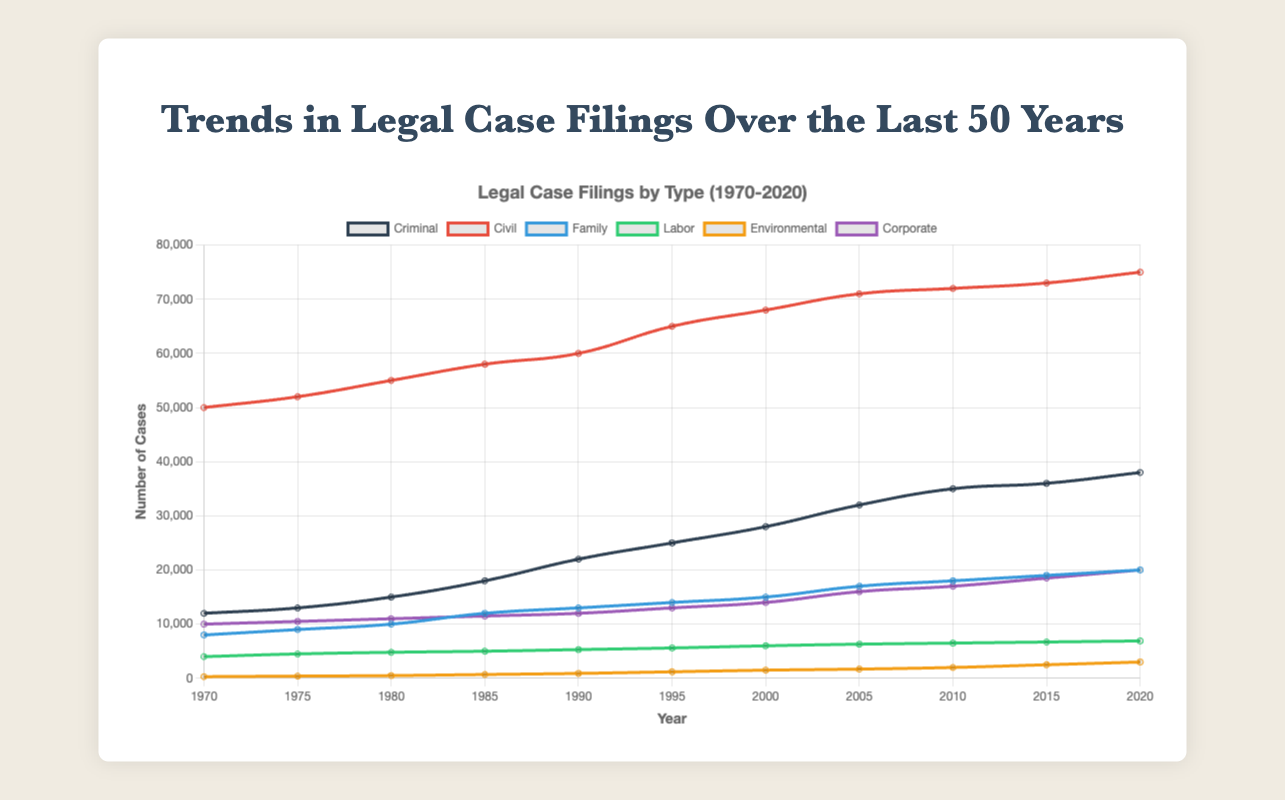What's the general trend in the number of criminal cases from 1970 to 2020? Observing the line for "Criminal" cases in the plot, there is a general upward trend. Starting at 12,000 cases in 1970 and reaching 38,000 cases in 2020, it indicates steady growth over the years.
Answer: Upward trend Which type of case had the highest number in 2020? Looking at the values in 2020, "Civil" cases reached 75,000, which is higher than any other case type.
Answer: Civil In which year did family cases exceed 10,000 for the first time? Trace the "Family" line until it crosses 10,000. This occurs between 1975 and 1980, so the specific year based on the data context, it's around 1980.
Answer: 1980 Around which year do environmental cases start becoming significant in number? The "Environmental" cases line shows a noticeable increase around 1985 when the number reaches 700, up from 500.
Answer: Around 1985 How do the number of labor cases compare to corporate cases in the year 2000? Refer to the graph and compare the two lines for the year 2000. Labor cases are around 6,000, whereas corporate cases are around 14,000, indicating that corporate cases are higher.
Answer: Corporate cases are higher What's the average number of civil cases filed per year over the 50 years? Sum the number of civil cases: 50000 + 52000 + 55000 + 58000 + 60000 + 65000 + 68000 + 71000 + 72000 + 73000 + 75000 = 699000. Divide this by the number of years (11). So, 699000 / 11 = 63545.45.
Answer: 63545.45 In which year did criminal cases surpass 30,000 for the first time? Examine the "Criminal" line until it crosses 30,000. This occurs between 2000 and 2005, specifically around 2005.
Answer: 2005 Compare the increase in the number of environmental cases and corporate cases between 1990 and 2020. Environmental cases grew from 900 to 3000, an increase of 2100. Corporate cases grew from 12000 to 20000, an increase of 8000. Though both increased, corporate cases had a much larger increase over this period.
Answer: Corporate increased more What’s the difference in the number of family cases and labor cases in 2010? In 2010, the number of family cases is 18,000, and labor cases are 6,500. Calculate the difference: 18,000 - 6,500 = 11,500.
Answer: 11,500 Which case type saw the most significant relative growth from 1970 to 2020? By comparing overall growth percentages, "Environmental" increased from 300 to 3000, a 900% increase. This relative growth is the most significant.
Answer: Environmental 